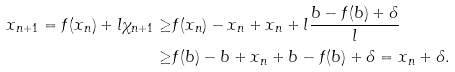Convert formula to latex. <formula><loc_0><loc_0><loc_500><loc_500>x _ { n + 1 } = f ( x _ { n } ) + l \chi _ { n + 1 } \geq & f ( x _ { n } ) - x _ { n } + x _ { n } + l \frac { b - f ( b ) + \delta } { l } \\ \geq & f ( b ) - b + x _ { n } + b - f ( b ) + \delta = x _ { n } + \delta .</formula> 